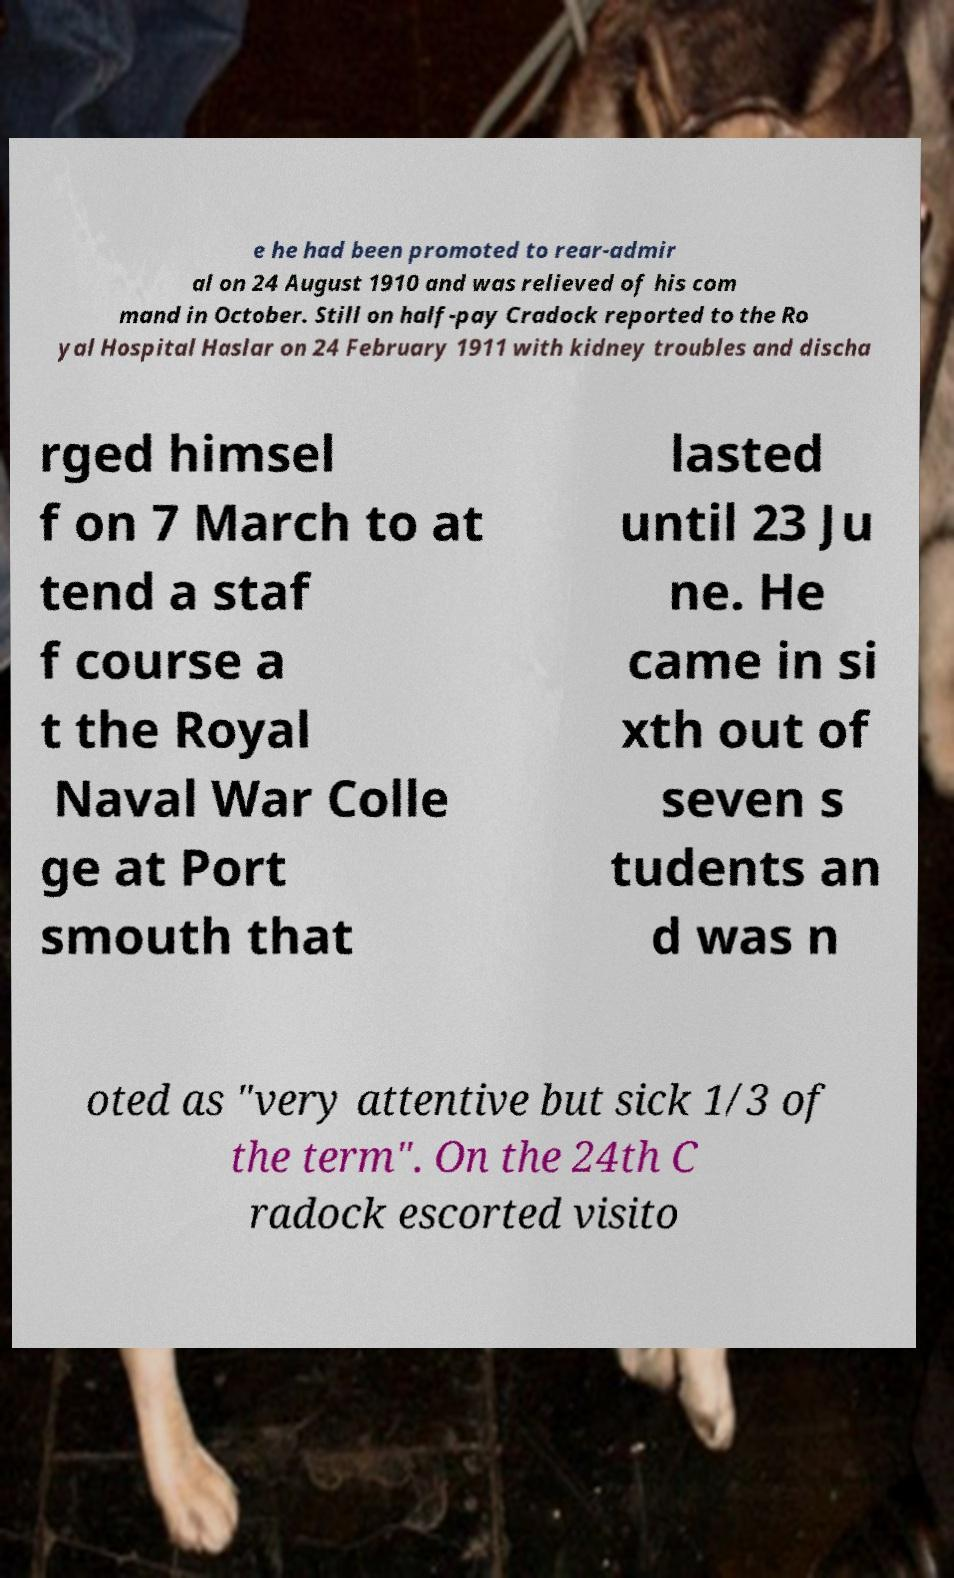Could you extract and type out the text from this image? e he had been promoted to rear-admir al on 24 August 1910 and was relieved of his com mand in October. Still on half-pay Cradock reported to the Ro yal Hospital Haslar on 24 February 1911 with kidney troubles and discha rged himsel f on 7 March to at tend a staf f course a t the Royal Naval War Colle ge at Port smouth that lasted until 23 Ju ne. He came in si xth out of seven s tudents an d was n oted as "very attentive but sick 1/3 of the term". On the 24th C radock escorted visito 